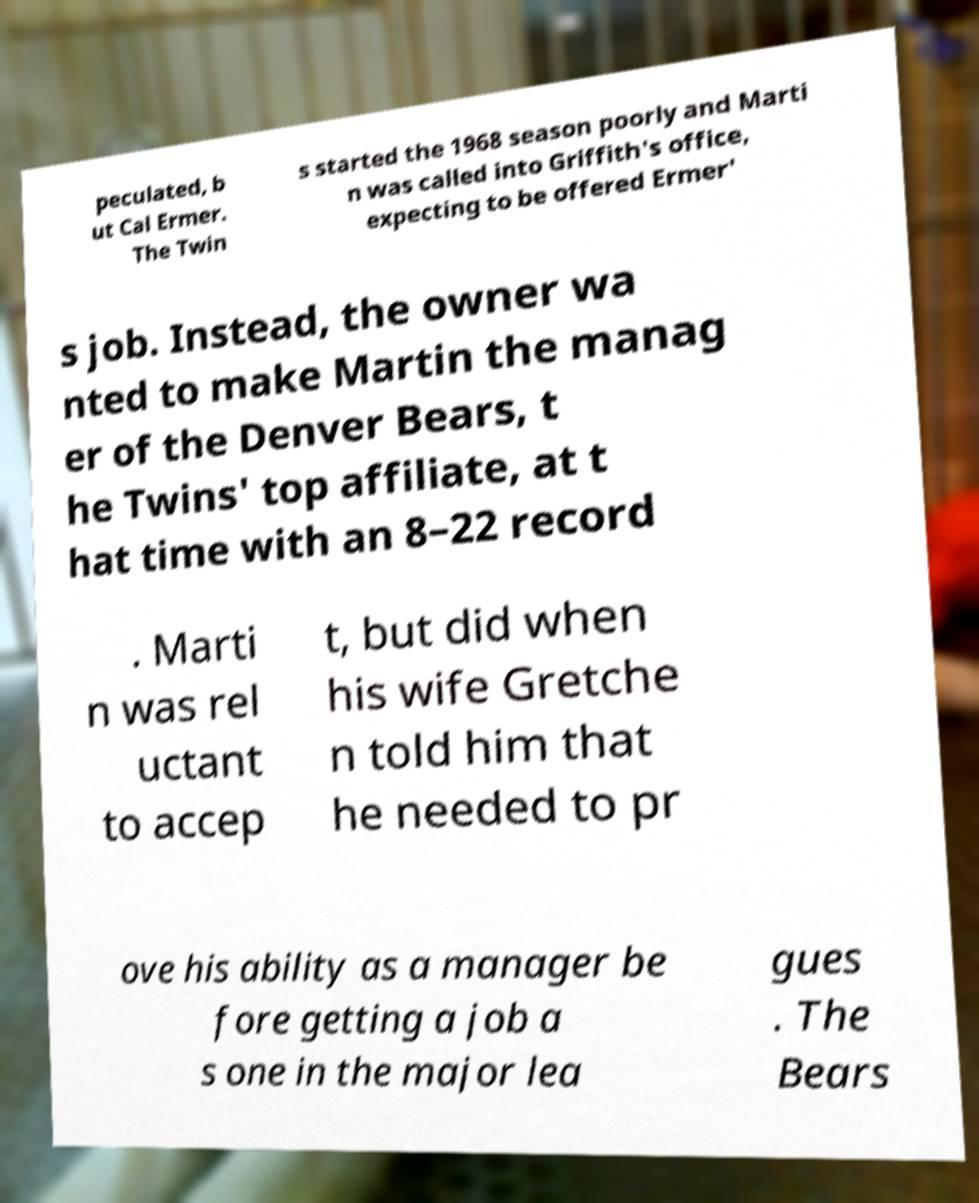Please read and relay the text visible in this image. What does it say? peculated, b ut Cal Ermer. The Twin s started the 1968 season poorly and Marti n was called into Griffith's office, expecting to be offered Ermer' s job. Instead, the owner wa nted to make Martin the manag er of the Denver Bears, t he Twins' top affiliate, at t hat time with an 8–22 record . Marti n was rel uctant to accep t, but did when his wife Gretche n told him that he needed to pr ove his ability as a manager be fore getting a job a s one in the major lea gues . The Bears 